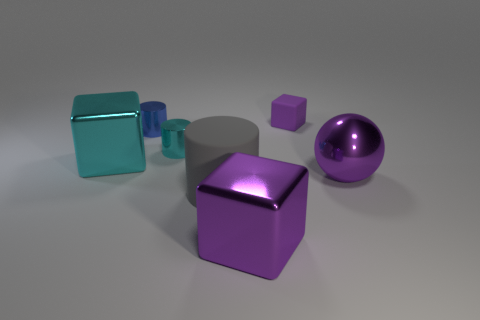There is a tiny thing that is the same color as the ball; what is it made of?
Ensure brevity in your answer.  Rubber. What material is the gray cylinder that is the same size as the purple sphere?
Keep it short and to the point. Rubber. What number of big objects are either purple metal spheres or red metallic cylinders?
Your answer should be compact. 1. What number of things are either tiny cylinders to the right of the blue metallic object or objects in front of the small cyan object?
Ensure brevity in your answer.  5. Are there fewer tiny gray matte balls than small blue objects?
Provide a succinct answer. Yes. What shape is the cyan thing that is the same size as the blue object?
Your answer should be very brief. Cylinder. How many other objects are there of the same color as the big ball?
Your answer should be compact. 2. How many tiny cylinders are there?
Keep it short and to the point. 2. What number of blocks are both in front of the matte cube and right of the cyan block?
Your answer should be compact. 1. What material is the small blue object?
Your response must be concise. Metal. 